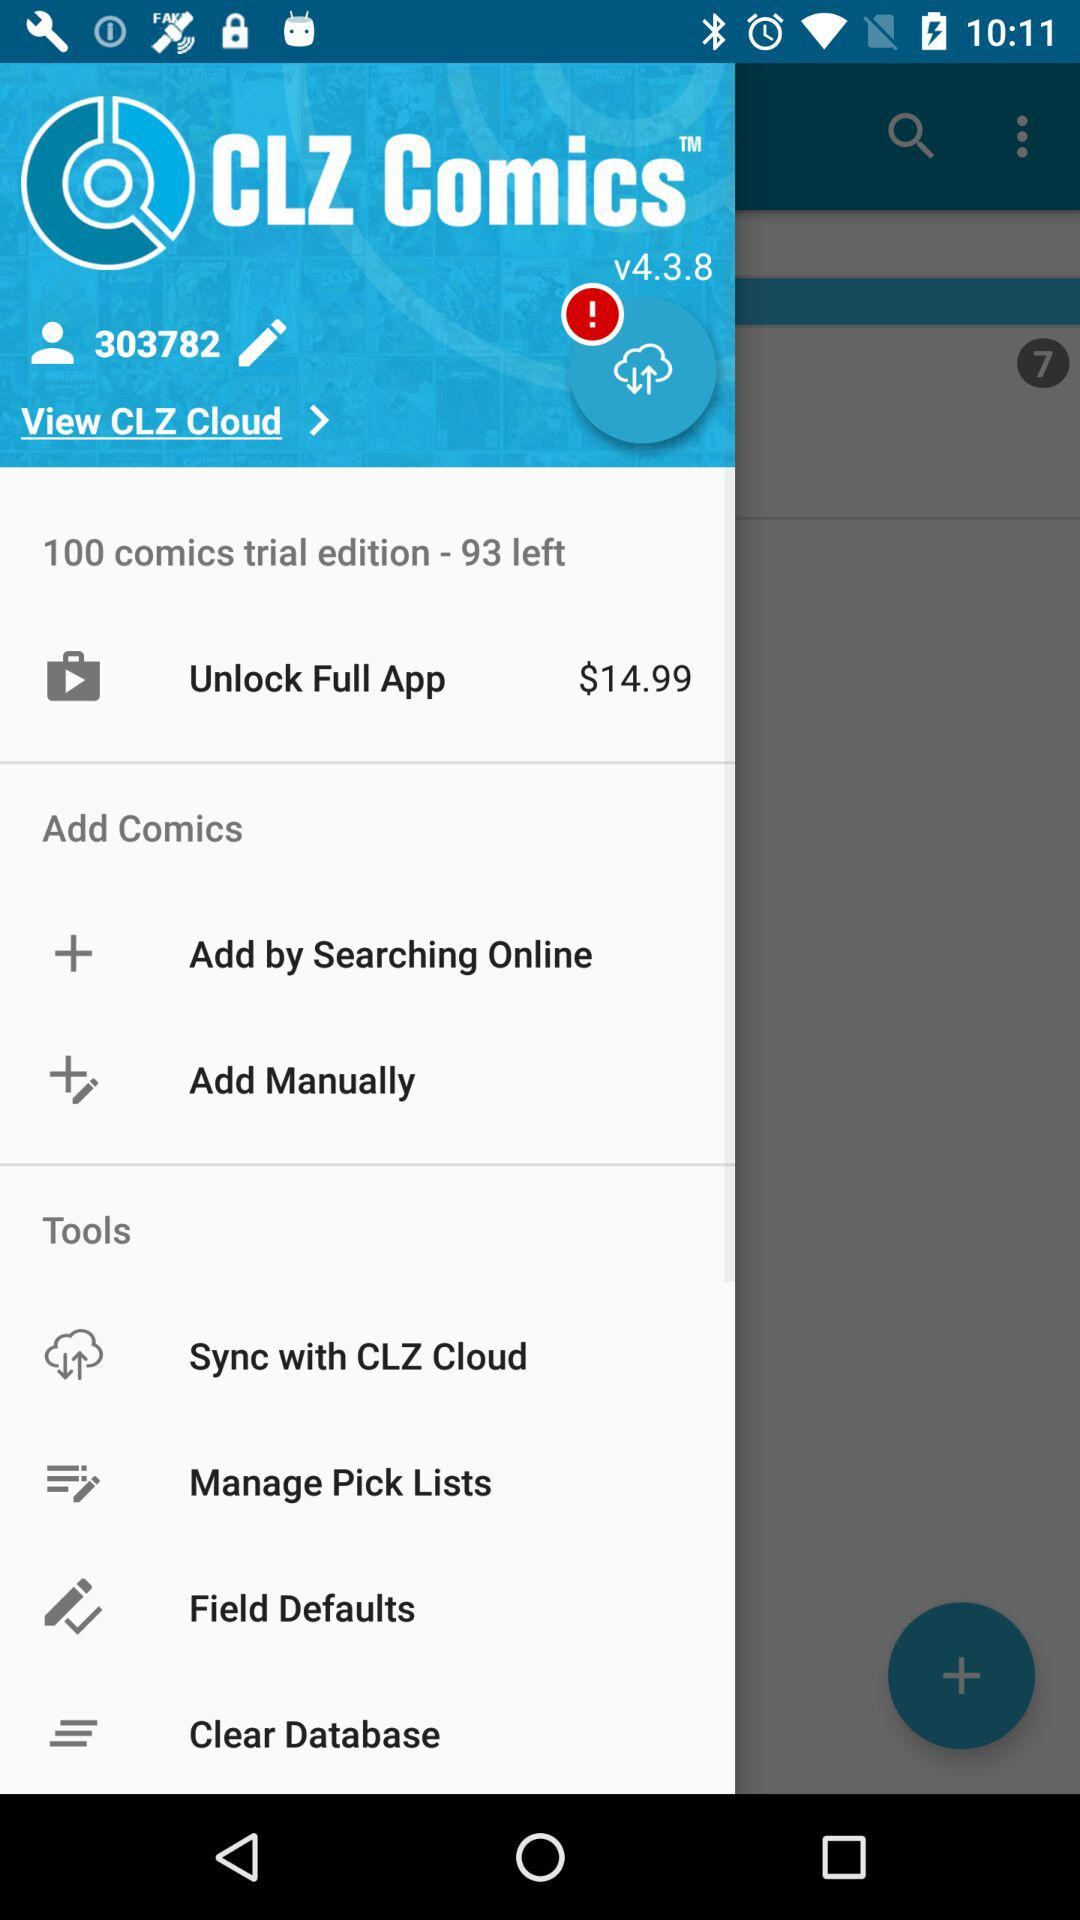What is the name of the application? The name of the application is "CLZ Comics". 